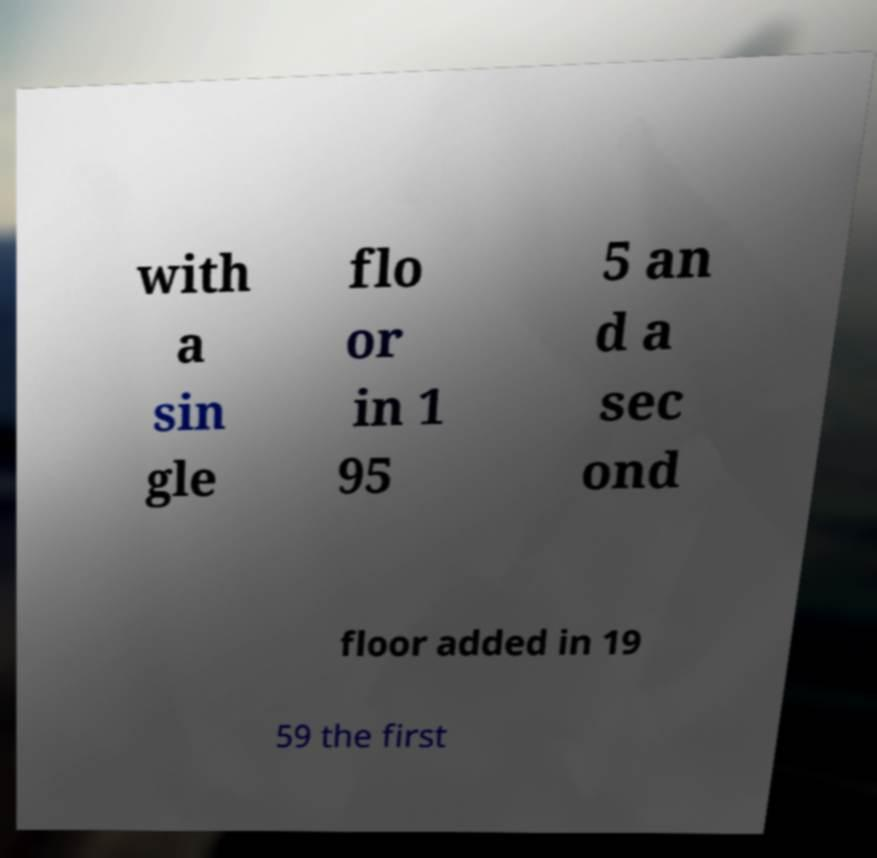I need the written content from this picture converted into text. Can you do that? with a sin gle flo or in 1 95 5 an d a sec ond floor added in 19 59 the first 